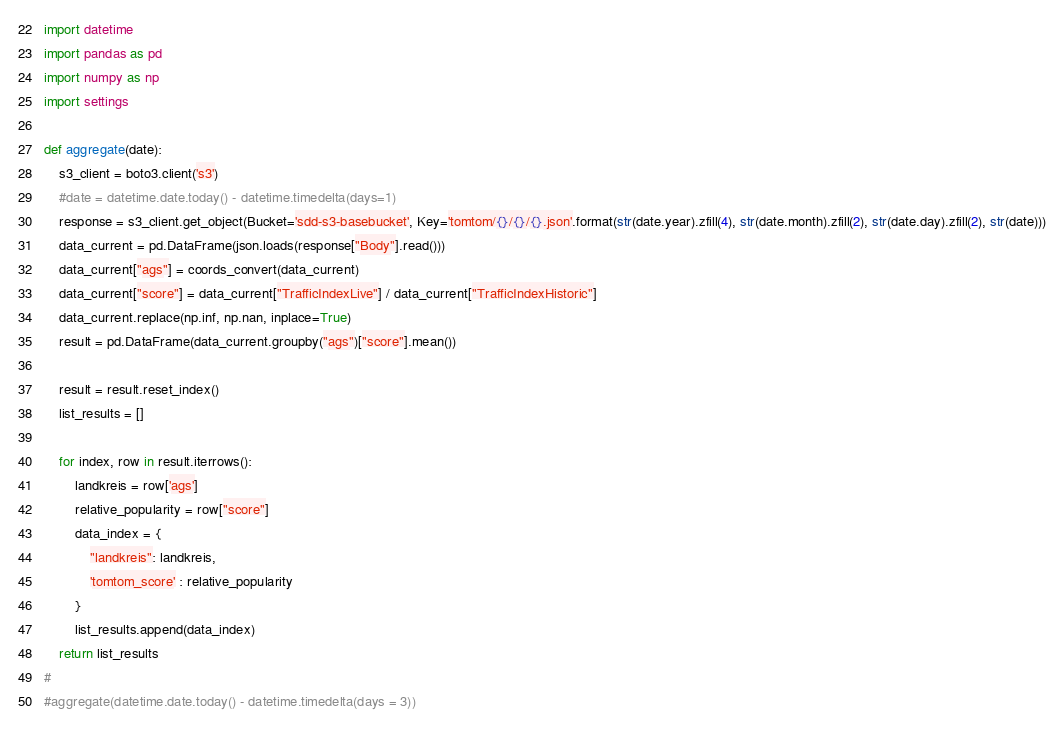<code> <loc_0><loc_0><loc_500><loc_500><_Python_>import datetime
import pandas as pd
import numpy as np
import settings

def aggregate(date):
    s3_client = boto3.client('s3')
    #date = datetime.date.today() - datetime.timedelta(days=1)
    response = s3_client.get_object(Bucket='sdd-s3-basebucket', Key='tomtom/{}/{}/{}.json'.format(str(date.year).zfill(4), str(date.month).zfill(2), str(date.day).zfill(2), str(date)))
    data_current = pd.DataFrame(json.loads(response["Body"].read()))
    data_current["ags"] = coords_convert(data_current)
    data_current["score"] = data_current["TrafficIndexLive"] / data_current["TrafficIndexHistoric"]
    data_current.replace(np.inf, np.nan, inplace=True)
    result = pd.DataFrame(data_current.groupby("ags")["score"].mean())

    result = result.reset_index()
    list_results = []

    for index, row in result.iterrows():
        landkreis = row['ags']
        relative_popularity = row["score"]
        data_index = {
            "landkreis": landkreis,
            'tomtom_score' : relative_popularity
        }
        list_results.append(data_index)
    return list_results
#
#aggregate(datetime.date.today() - datetime.timedelta(days = 3))
</code> 